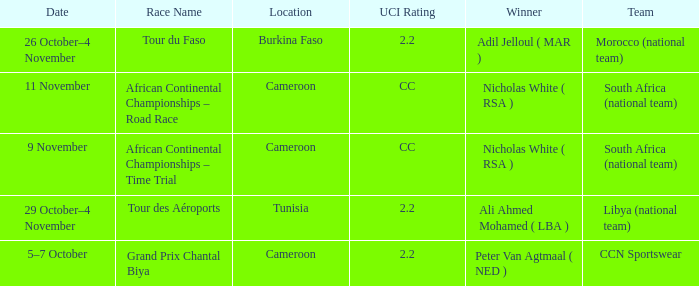Who is the winner of the race in Burkina Faso? Adil Jelloul ( MAR ). 